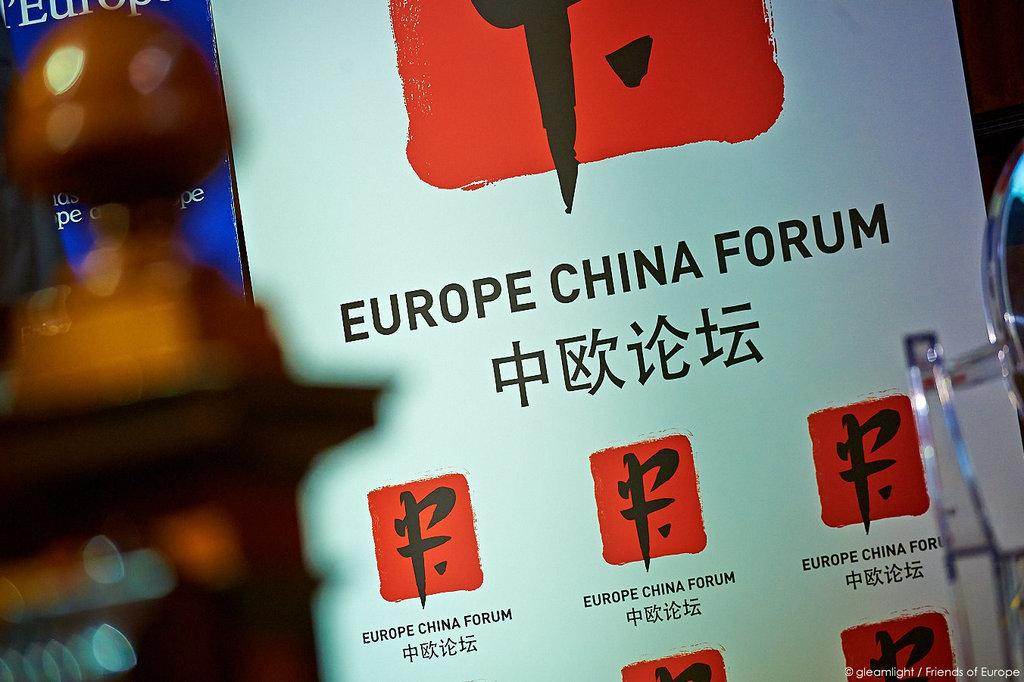<image>
Provide a brief description of the given image. A brocure for a Europe China Forum with both Chinese and English text. 